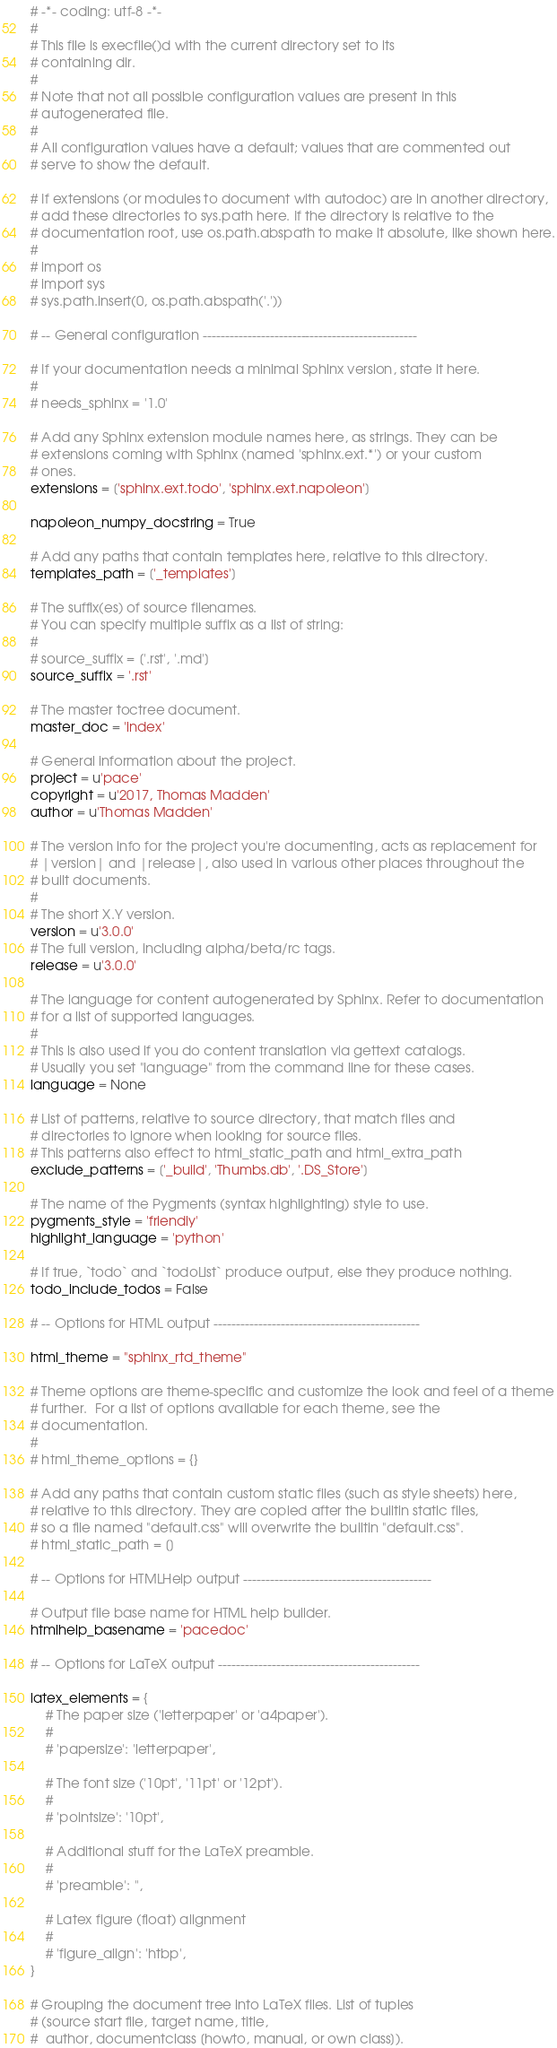Convert code to text. <code><loc_0><loc_0><loc_500><loc_500><_Python_># -*- coding: utf-8 -*-
#
# This file is execfile()d with the current directory set to its
# containing dir.
#
# Note that not all possible configuration values are present in this
# autogenerated file.
#
# All configuration values have a default; values that are commented out
# serve to show the default.

# If extensions (or modules to document with autodoc) are in another directory,
# add these directories to sys.path here. If the directory is relative to the
# documentation root, use os.path.abspath to make it absolute, like shown here.
#
# import os
# import sys
# sys.path.insert(0, os.path.abspath('.'))

# -- General configuration ------------------------------------------------

# If your documentation needs a minimal Sphinx version, state it here.
#
# needs_sphinx = '1.0'

# Add any Sphinx extension module names here, as strings. They can be
# extensions coming with Sphinx (named 'sphinx.ext.*') or your custom
# ones.
extensions = ['sphinx.ext.todo', 'sphinx.ext.napoleon']

napoleon_numpy_docstring = True

# Add any paths that contain templates here, relative to this directory.
templates_path = ['_templates']

# The suffix(es) of source filenames.
# You can specify multiple suffix as a list of string:
#
# source_suffix = ['.rst', '.md']
source_suffix = '.rst'

# The master toctree document.
master_doc = 'index'

# General information about the project.
project = u'pace'
copyright = u'2017, Thomas Madden'
author = u'Thomas Madden'

# The version info for the project you're documenting, acts as replacement for
# |version| and |release|, also used in various other places throughout the
# built documents.
#
# The short X.Y version.
version = u'3.0.0'
# The full version, including alpha/beta/rc tags.
release = u'3.0.0'

# The language for content autogenerated by Sphinx. Refer to documentation
# for a list of supported languages.
#
# This is also used if you do content translation via gettext catalogs.
# Usually you set "language" from the command line for these cases.
language = None

# List of patterns, relative to source directory, that match files and
# directories to ignore when looking for source files.
# This patterns also effect to html_static_path and html_extra_path
exclude_patterns = ['_build', 'Thumbs.db', '.DS_Store']

# The name of the Pygments (syntax highlighting) style to use.
pygments_style = 'friendly'
highlight_language = 'python'

# If true, `todo` and `todoList` produce output, else they produce nothing.
todo_include_todos = False

# -- Options for HTML output ----------------------------------------------

html_theme = "sphinx_rtd_theme"

# Theme options are theme-specific and customize the look and feel of a theme
# further.  For a list of options available for each theme, see the
# documentation.
#
# html_theme_options = {}

# Add any paths that contain custom static files (such as style sheets) here,
# relative to this directory. They are copied after the builtin static files,
# so a file named "default.css" will overwrite the builtin "default.css".
# html_static_path = []

# -- Options for HTMLHelp output ------------------------------------------

# Output file base name for HTML help builder.
htmlhelp_basename = 'pacedoc'

# -- Options for LaTeX output ---------------------------------------------

latex_elements = {
    # The paper size ('letterpaper' or 'a4paper').
    #
    # 'papersize': 'letterpaper',

    # The font size ('10pt', '11pt' or '12pt').
    #
    # 'pointsize': '10pt',

    # Additional stuff for the LaTeX preamble.
    #
    # 'preamble': '',

    # Latex figure (float) alignment
    #
    # 'figure_align': 'htbp',
}

# Grouping the document tree into LaTeX files. List of tuples
# (source start file, target name, title,
#  author, documentclass [howto, manual, or own class]).</code> 